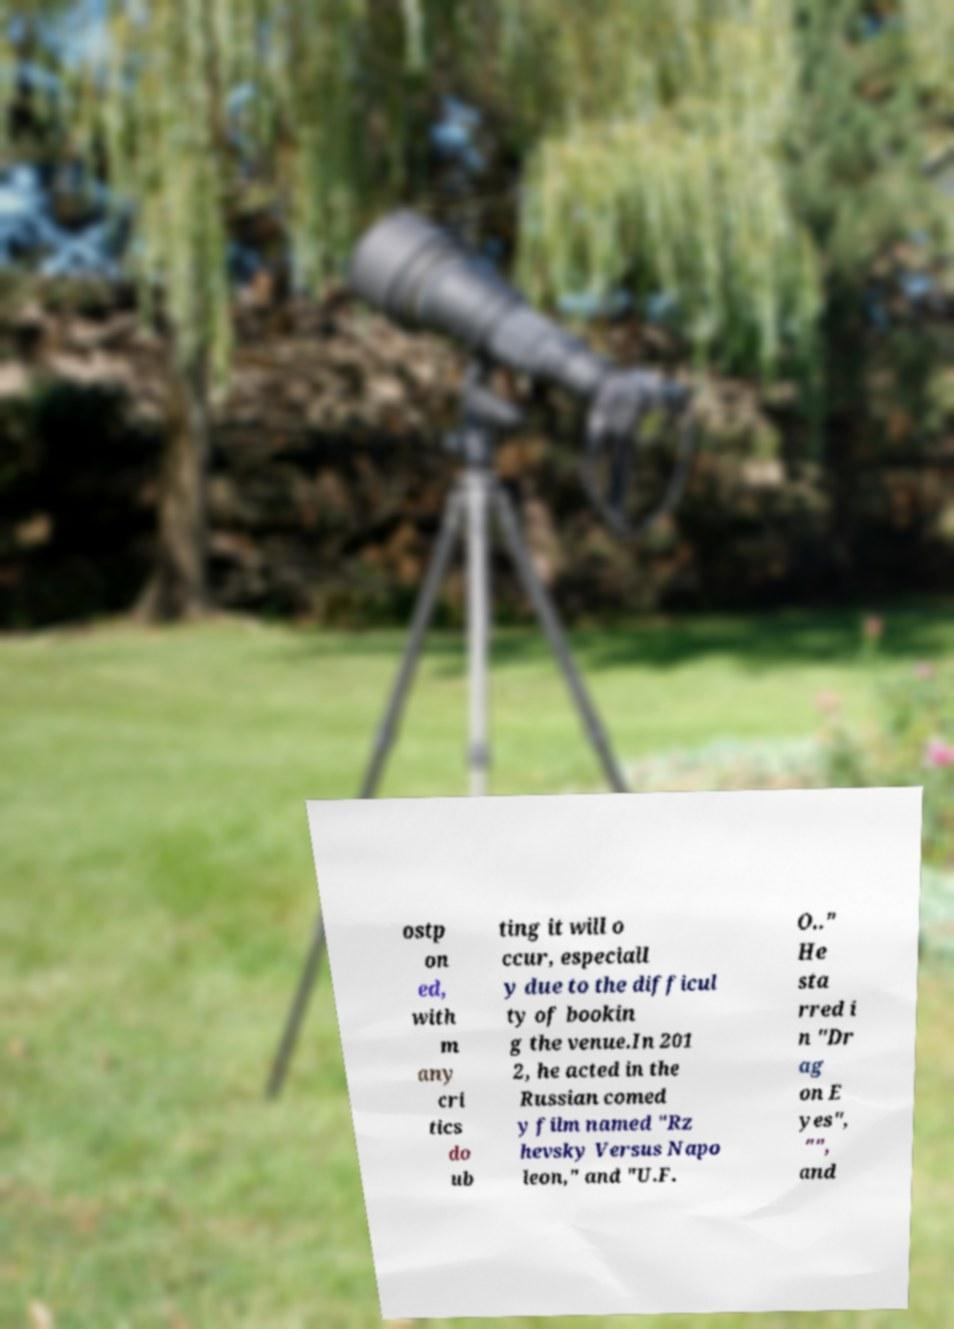What messages or text are displayed in this image? I need them in a readable, typed format. ostp on ed, with m any cri tics do ub ting it will o ccur, especiall y due to the difficul ty of bookin g the venue.In 201 2, he acted in the Russian comed y film named "Rz hevsky Versus Napo leon," and "U.F. O.." He sta rred i n "Dr ag on E yes", "", and 